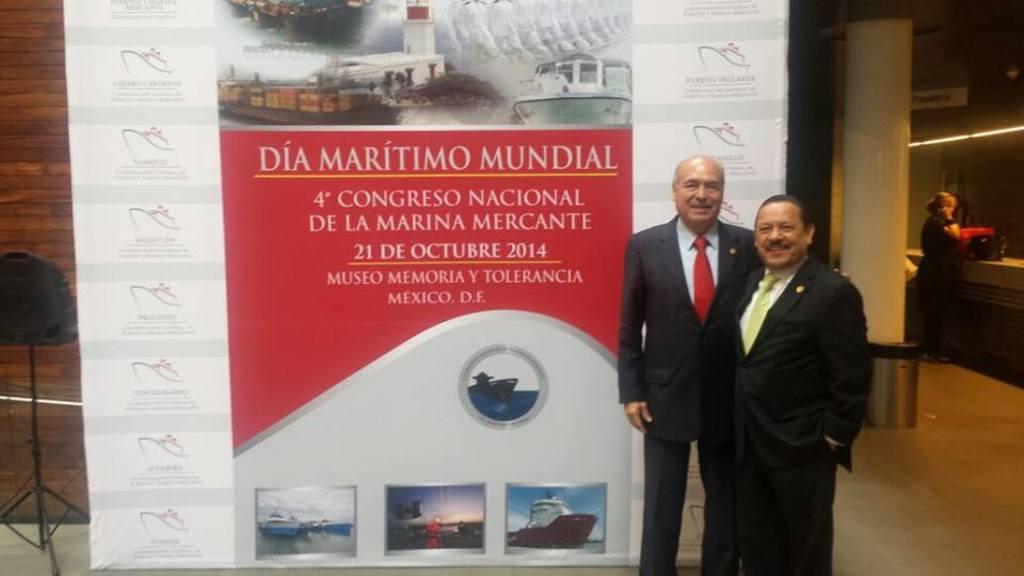In one or two sentences, can you explain what this image depicts? In this image I can see there are persons standing on the floor. At the back there is a wall, banner and a stand. At the side there is a box and a pillar. 